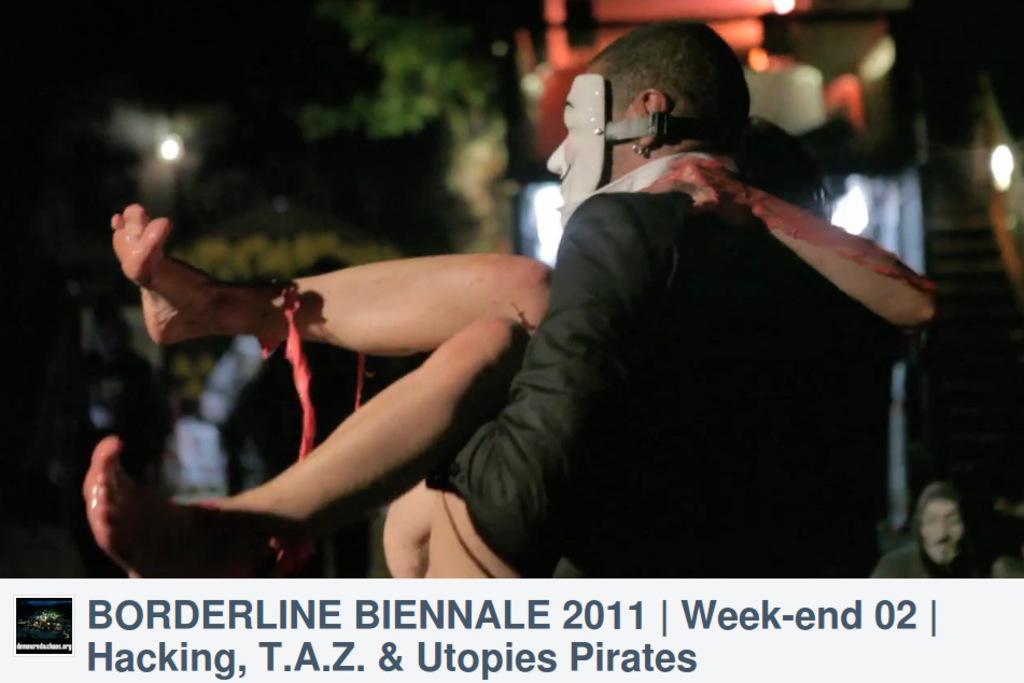How would you summarize this image in a sentence or two? In this image, we can see a man wearing a mask on the face, he is carrying a woman, in the background we can see the trees and there is a building. 